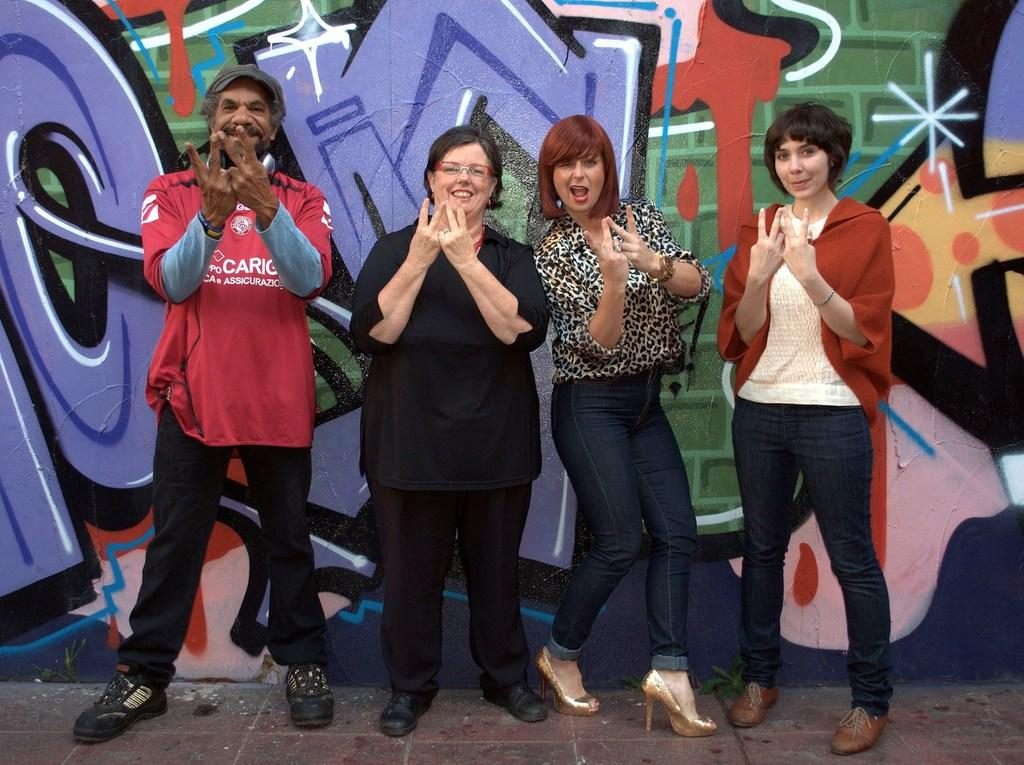How many people are in the image? There are four persons in the image. What are the people doing in the image? The persons are standing on the floor and smiling. What can be seen in the background of the image? There is graffiti painting on the wall in the background of the image. What type of horn can be heard in the image? There is no horn present in the image, and therefore no sound can be heard. What is the visibility like in the image due to the mist? There is no mention of mist in the image, so it cannot be determined if visibility is affected. 